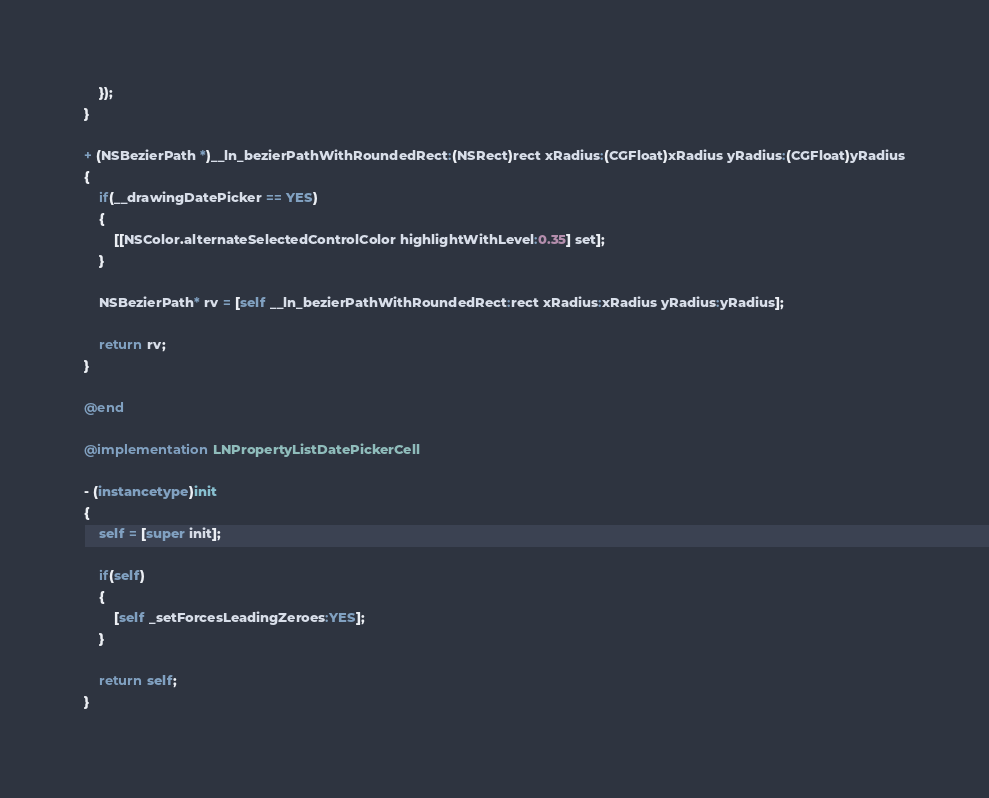Convert code to text. <code><loc_0><loc_0><loc_500><loc_500><_ObjectiveC_>	});
}

+ (NSBezierPath *)__ln_bezierPathWithRoundedRect:(NSRect)rect xRadius:(CGFloat)xRadius yRadius:(CGFloat)yRadius
{
	if(__drawingDatePicker == YES)
	{
		[[NSColor.alternateSelectedControlColor highlightWithLevel:0.35] set];
	}
	
	NSBezierPath* rv = [self __ln_bezierPathWithRoundedRect:rect xRadius:xRadius yRadius:yRadius];
	
	return rv;
}

@end

@implementation LNPropertyListDatePickerCell

- (instancetype)init
{
	self = [super init];
	
	if(self)
	{
		[self _setForcesLeadingZeroes:YES];
	}
	
	return self;
}
</code> 